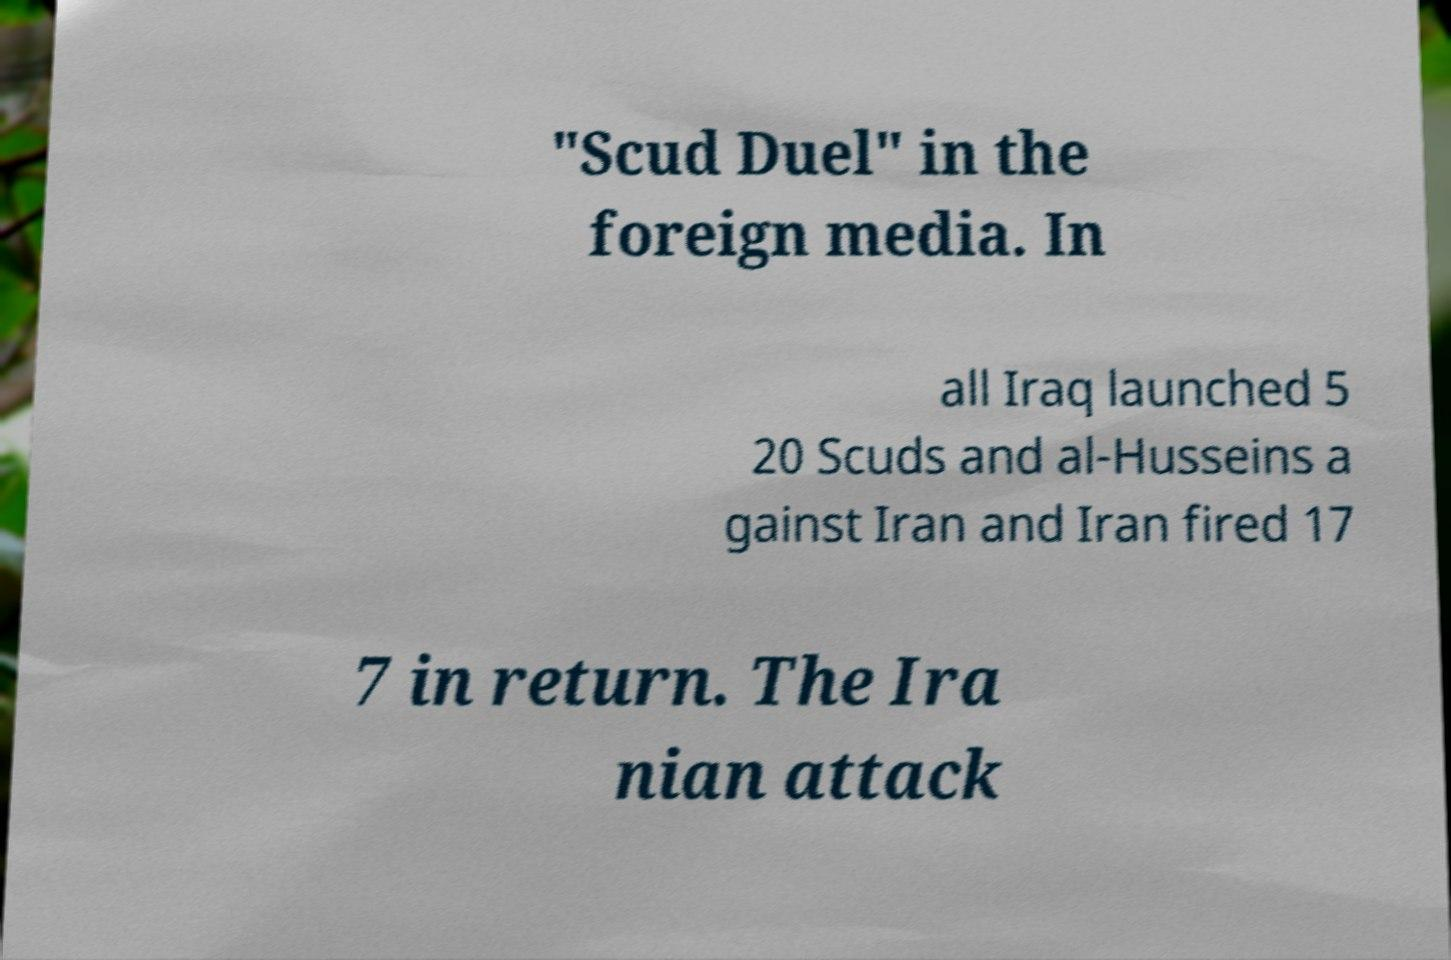Could you assist in decoding the text presented in this image and type it out clearly? "Scud Duel" in the foreign media. In all Iraq launched 5 20 Scuds and al-Husseins a gainst Iran and Iran fired 17 7 in return. The Ira nian attack 